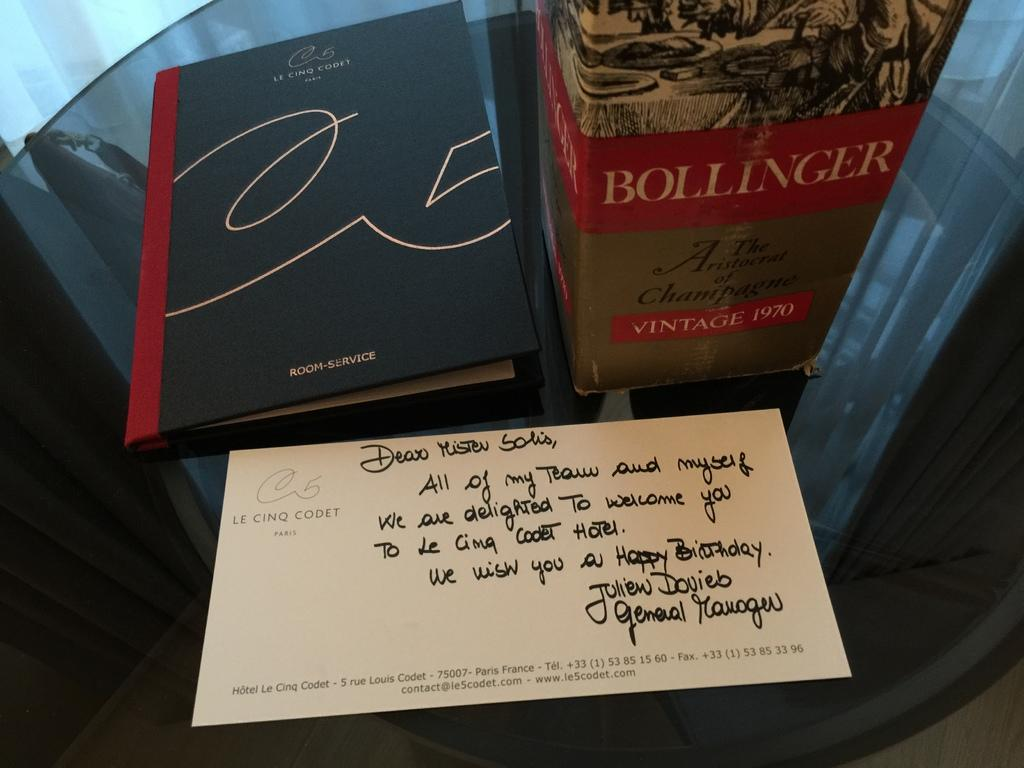Provide a one-sentence caption for the provided image. Book and a bottle of champagne from Bollinger with a postcard. 